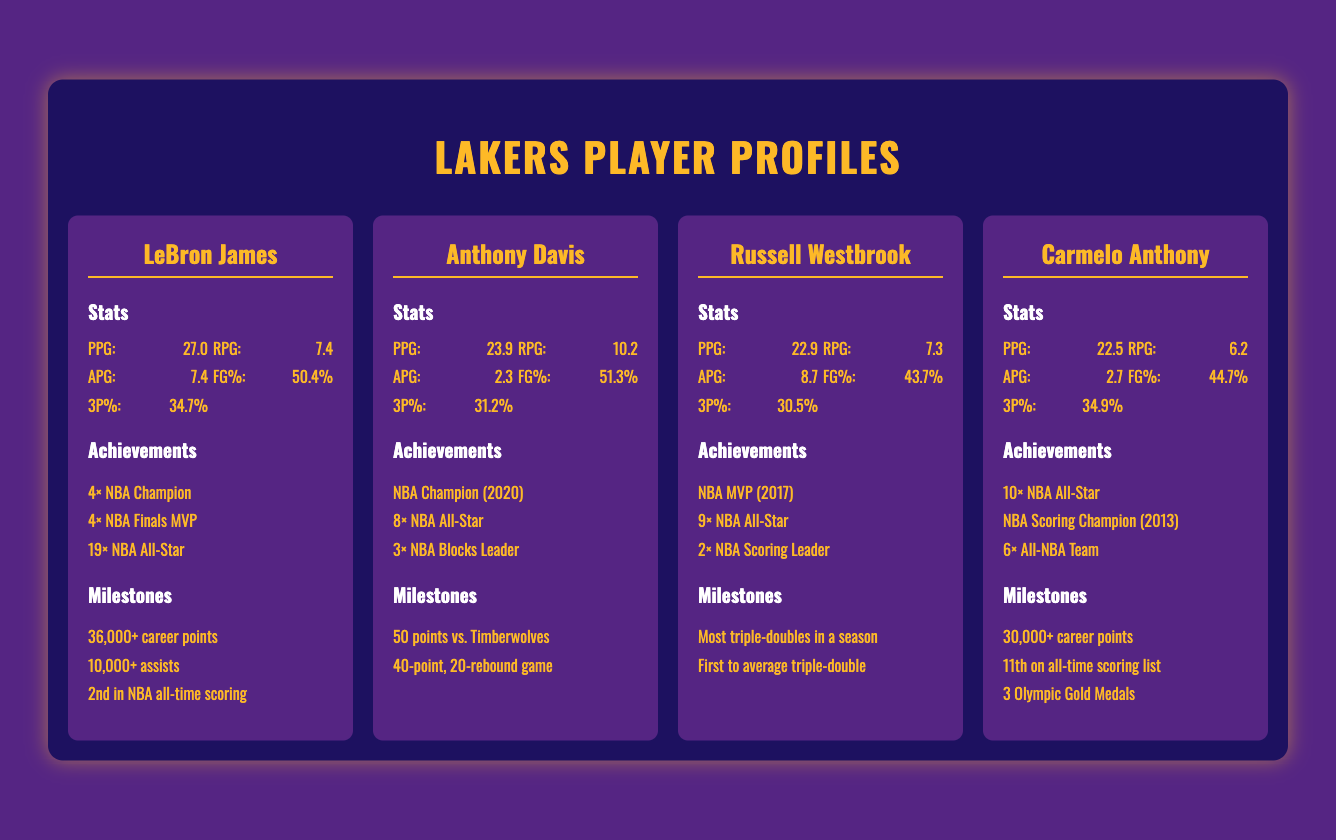What is LeBron James' PPG? LeBron James' Points Per Game (PPG) is listed in the document under his stats section.
Answer: 27.0 How many NBA Championships has Anthony Davis won? Anthony Davis's achievements include the number of NBA Championships he has won as noted in the document.
Answer: 1 What is the FG% of Russell Westbrook? The field goal percentage (FG%) for Russell Westbrook is provided in his stats section.
Answer: 43.7% Which player has the most All-Star selections? The document compares the achievements of the players and mentions the number of All-Star appearances for each player, helping to determine the one with the most.
Answer: LeBron James How many career points has Carmelo Anthony scored? The document highlights significant milestones for players, including career points for Carmelo Anthony.
Answer: 30,000+ Which player is 2nd in NBA all-time scoring? The document lists various milestones where players are recognized for their achievements, including LeBron James's ranking in scoring.
Answer: LeBron James What is Anthony Davis' RPG? The document specifies the Rebounds Per Game (RPG) statistic for Anthony Davis in his stats section.
Answer: 10.2 Who is the NBA MVP of 2017? The achievements for Russell Westbrook include the honor of being named NBA MVP in a specific year, as documented.
Answer: Russell Westbrook How many Olympic Gold Medals does Carmelo Anthony have? The document mentions Carmelo Anthony's accomplishments, specifically noting the number of Olympic Gold Medals he has won.
Answer: 3 